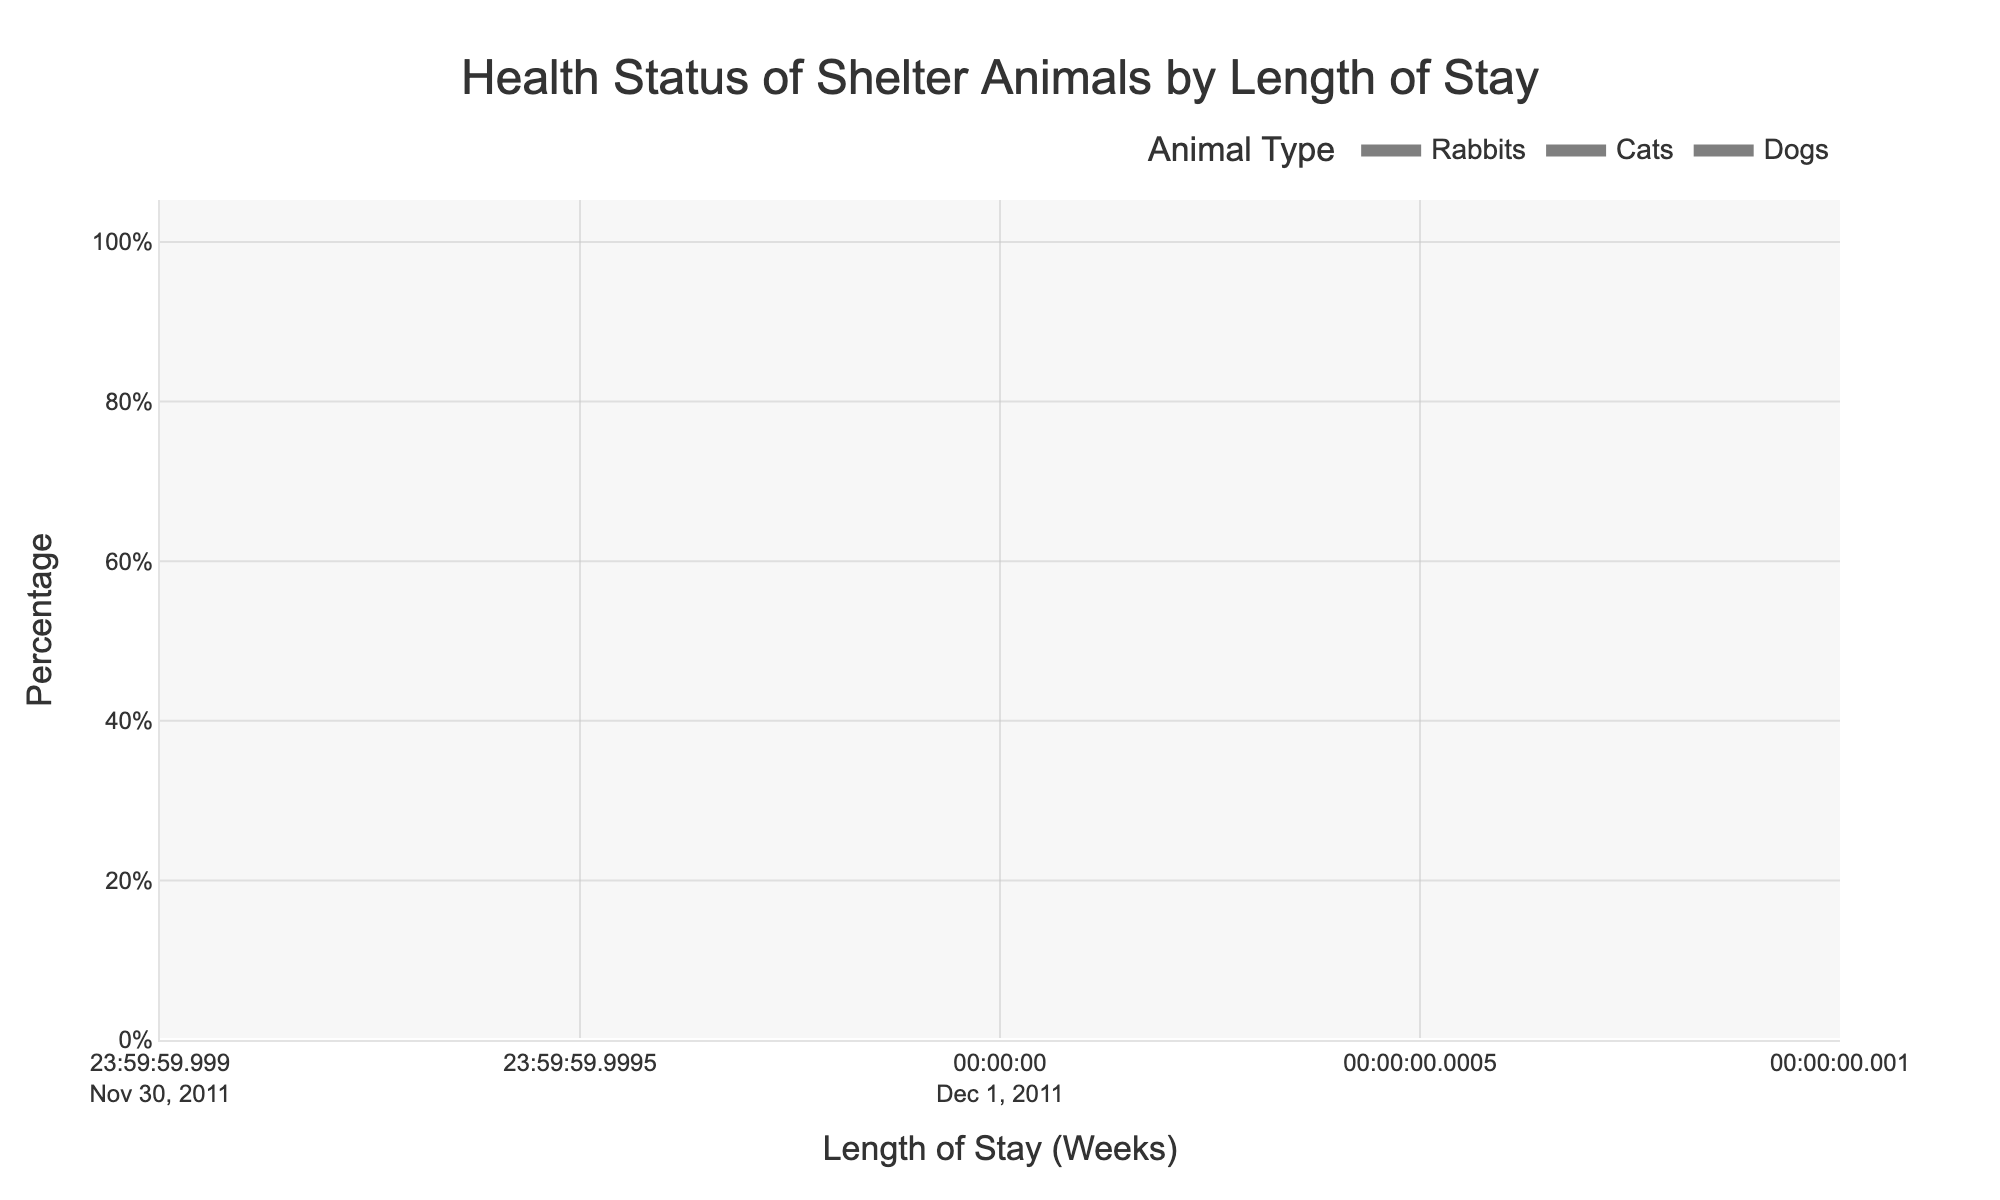What's the title of the figure? Look at the text displayed at the top of the plot.
Answer: Health Status of Shelter Animals by Length of Stay What are the labels of the x-axis and y-axis? Check the text displayed along the horizontal and vertical edges of the plot.
Answer: x-axis: Length of Stay (Weeks), y-axis: Percentage Which animal type has the highest percentage of healthy animals in the first 1-2 weeks? Look at the sections of the figure corresponding to the first 1-2 weeks for each animal type and compare the heights of the "Healthy" stack.
Answer: Rabbits For the length of stay (weeks) of 3-4, which animal has the highest count of minor illness? Find the stacks corresponding to the "Minor Illness" health status for the length of stay 3-4 weeks for each type of animal.
Answer: Dogs What trend do you notice in the percentage of healthy animals as the length of stay increases for dogs? Observe the stacks of "Healthy" in the figure for dogs and note the changes from 1-2 weeks to 11-12 weeks.
Answer: The percentage decreases What is the combined percentage of cats and dogs with severe illness at a length of stay of 5-6 weeks? Add the percentages of "Severely Ill" for cats and dogs at 5-6 weeks.
Answer: 5 + 3 = 8% How does the percentage of minor illness in cats at 3-4 weeks compare to that at 9-10 weeks? Compare the heights of the "Minor Illness" stacks for cats at 3-4 weeks and 9-10 weeks.
Answer: Increases Which animal type shows the smallest increase in severe illness percentage from 1-2 weeks to 11-12 weeks? Compare the changes in the height of the "Severely Ill" stacks from 1-2 weeks to 11-12 weeks for each animal type.
Answer: Rabbits In the 7-8 weeks category, what is the approximate difference in the percentage of healthy animals between cats and rabbits? Subtract the percentage of "Healthy" animals for cats from that for rabbits at 7-8 weeks.
Answer: 40% - 30% = 10% Which animal type has the most significant variation in minor illness over the different lengths of stay? Observe the variations in the height of the "Minor Illness" stacks across different weeks for each type of animal.
Answer: Dogs 